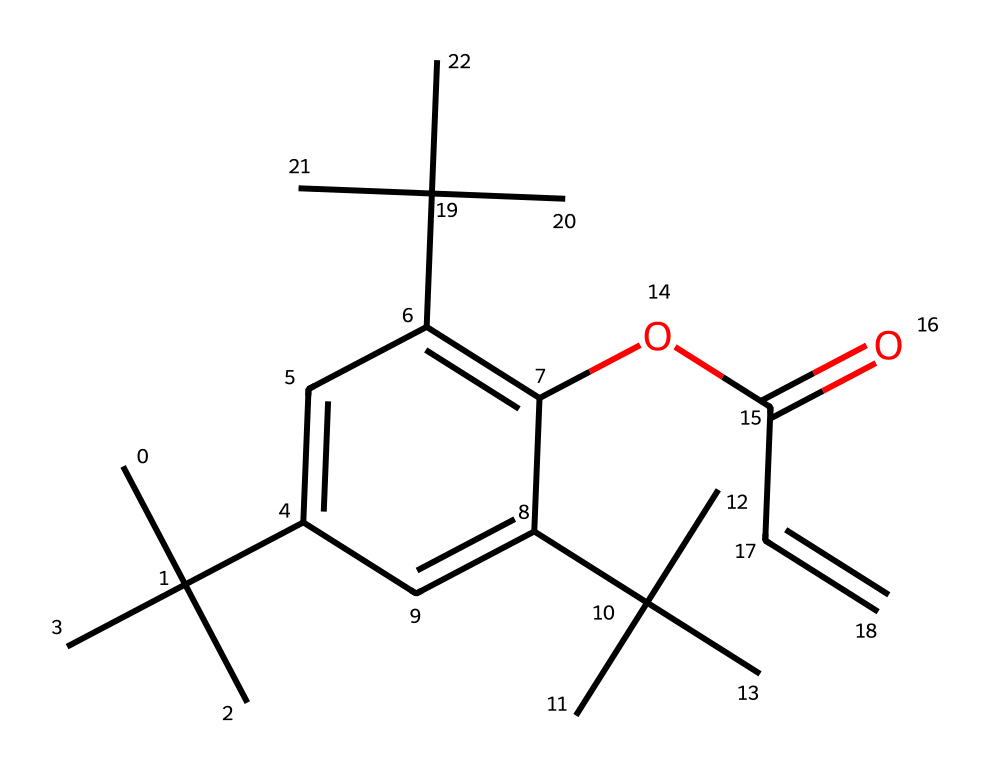What is the number of carbon atoms in this molecule? Analyzing the SMILES representation, there are 27 carbon atoms represented by 'C'. Each 'C' denotes a carbon atom, and counting them shows that the total is 27.
Answer: 27 What type of functional group is present in this structure? The presence of 'C(=O)' indicates a carbonyl group, specifically an ester functional group as it is attached to an oxygen and a carbon chain.
Answer: ester How many double bonds are present in this molecule? By examining the SMILES, the '=' character indicates double bonds. Counting these in the structure shows there are four double bonds in total.
Answer: 4 What is the likely state of this chemical at room temperature? Given that this is a photoresist and contains multiple carbon atoms and functional groups, it is likely to be a viscous liquid or solid at room temperature, based on similar compounds.
Answer: liquid What characteristics make this compound a negative photoresist? Negative photoresists undergo polymerization upon exposure to light, making the unexposed areas soluble. The presence of certain groups and structure facilitates this behavior, allowing for defined patterns on circuit boards.
Answer: polymerizable 